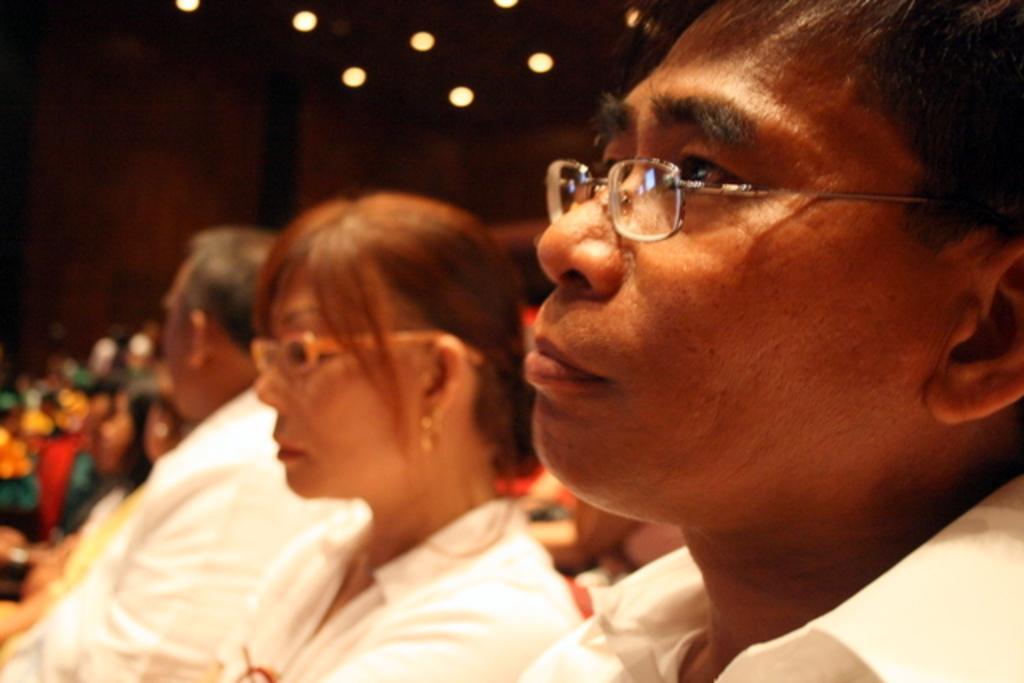Could you give a brief overview of what you see in this image? In this image we can see a few people sitting and at the top of the roof we can see some lights. 